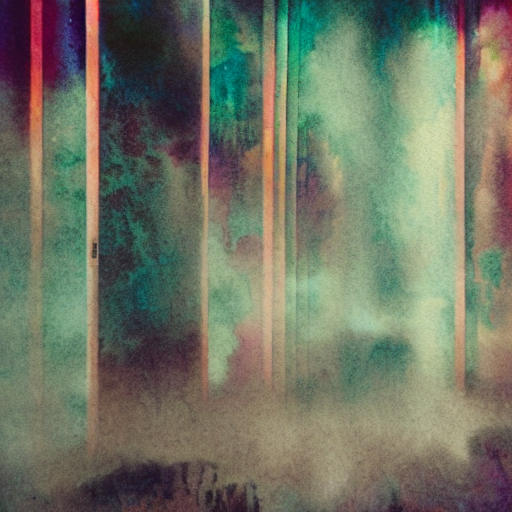What artistic elements can you identify in this abstract image? The image features a blend of vertical lines with varying widths and colors that intersect with softer, diffuse shapes and a hazy overlay. The color palette seems to include hints of teal, pink, and orange, creating a contrast that may evoke a sense of mystery or depth. While details are indistinct, the composition's interplay of linearity and obscurity can be interpreted as a visual metaphor for complexity amid structure. 